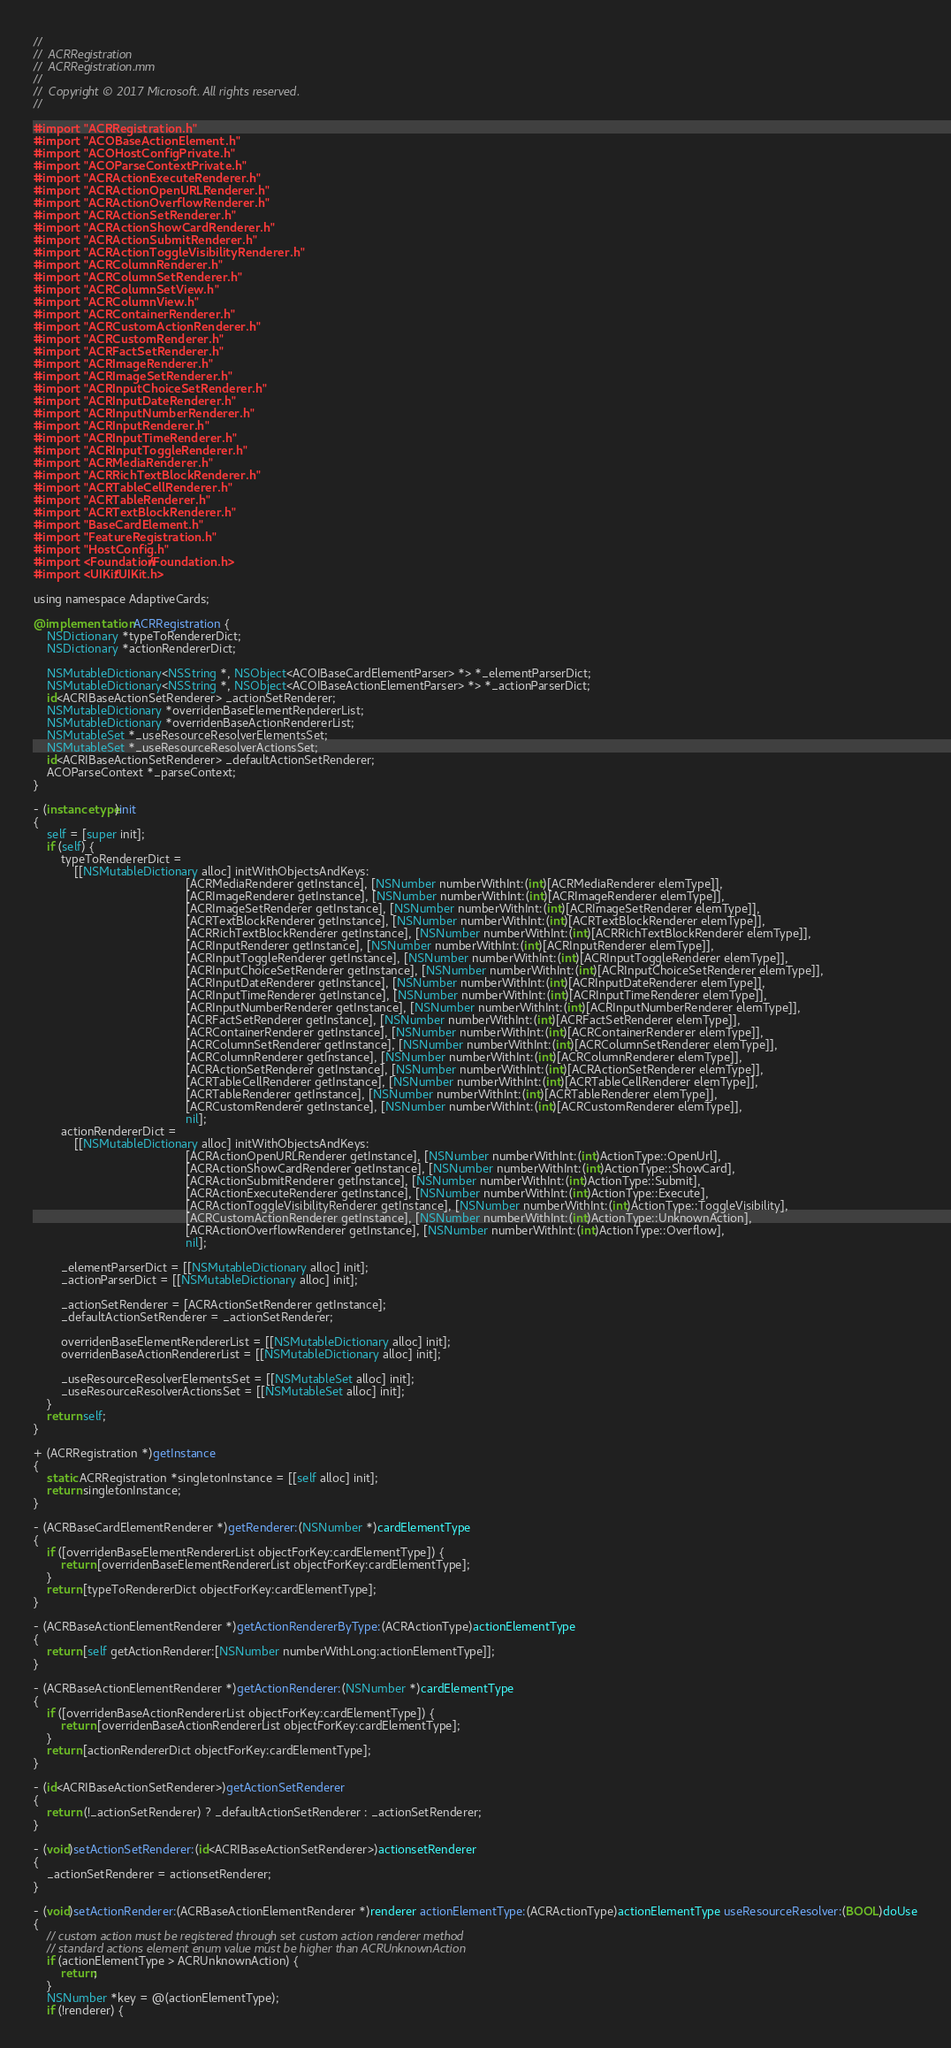Convert code to text. <code><loc_0><loc_0><loc_500><loc_500><_ObjectiveC_>//
//  ACRRegistration
//  ACRRegistration.mm
//
//  Copyright © 2017 Microsoft. All rights reserved.
//

#import "ACRRegistration.h"
#import "ACOBaseActionElement.h"
#import "ACOHostConfigPrivate.h"
#import "ACOParseContextPrivate.h"
#import "ACRActionExecuteRenderer.h"
#import "ACRActionOpenURLRenderer.h"
#import "ACRActionOverflowRenderer.h"
#import "ACRActionSetRenderer.h"
#import "ACRActionShowCardRenderer.h"
#import "ACRActionSubmitRenderer.h"
#import "ACRActionToggleVisibilityRenderer.h"
#import "ACRColumnRenderer.h"
#import "ACRColumnSetRenderer.h"
#import "ACRColumnSetView.h"
#import "ACRColumnView.h"
#import "ACRContainerRenderer.h"
#import "ACRCustomActionRenderer.h"
#import "ACRCustomRenderer.h"
#import "ACRFactSetRenderer.h"
#import "ACRImageRenderer.h"
#import "ACRImageSetRenderer.h"
#import "ACRInputChoiceSetRenderer.h"
#import "ACRInputDateRenderer.h"
#import "ACRInputNumberRenderer.h"
#import "ACRInputRenderer.h"
#import "ACRInputTimeRenderer.h"
#import "ACRInputToggleRenderer.h"
#import "ACRMediaRenderer.h"
#import "ACRRichTextBlockRenderer.h"
#import "ACRTableCellRenderer.h"
#import "ACRTableRenderer.h"
#import "ACRTextBlockRenderer.h"
#import "BaseCardElement.h"
#import "FeatureRegistration.h"
#import "HostConfig.h"
#import <Foundation/Foundation.h>
#import <UIKit/UIKit.h>

using namespace AdaptiveCards;

@implementation ACRRegistration {
    NSDictionary *typeToRendererDict;
    NSDictionary *actionRendererDict;

    NSMutableDictionary<NSString *, NSObject<ACOIBaseCardElementParser> *> *_elementParserDict;
    NSMutableDictionary<NSString *, NSObject<ACOIBaseActionElementParser> *> *_actionParserDict;
    id<ACRIBaseActionSetRenderer> _actionSetRenderer;
    NSMutableDictionary *overridenBaseElementRendererList;
    NSMutableDictionary *overridenBaseActionRendererList;
    NSMutableSet *_useResourceResolverElementsSet;
    NSMutableSet *_useResourceResolverActionsSet;
    id<ACRIBaseActionSetRenderer> _defaultActionSetRenderer;
    ACOParseContext *_parseContext;
}

- (instancetype)init
{
    self = [super init];
    if (self) {
        typeToRendererDict =
            [[NSMutableDictionary alloc] initWithObjectsAndKeys:
                                             [ACRMediaRenderer getInstance], [NSNumber numberWithInt:(int)[ACRMediaRenderer elemType]],
                                             [ACRImageRenderer getInstance], [NSNumber numberWithInt:(int)[ACRImageRenderer elemType]],
                                             [ACRImageSetRenderer getInstance], [NSNumber numberWithInt:(int)[ACRImageSetRenderer elemType]],
                                             [ACRTextBlockRenderer getInstance], [NSNumber numberWithInt:(int)[ACRTextBlockRenderer elemType]],
                                             [ACRRichTextBlockRenderer getInstance], [NSNumber numberWithInt:(int)[ACRRichTextBlockRenderer elemType]],
                                             [ACRInputRenderer getInstance], [NSNumber numberWithInt:(int)[ACRInputRenderer elemType]],
                                             [ACRInputToggleRenderer getInstance], [NSNumber numberWithInt:(int)[ACRInputToggleRenderer elemType]],
                                             [ACRInputChoiceSetRenderer getInstance], [NSNumber numberWithInt:(int)[ACRInputChoiceSetRenderer elemType]],
                                             [ACRInputDateRenderer getInstance], [NSNumber numberWithInt:(int)[ACRInputDateRenderer elemType]],
                                             [ACRInputTimeRenderer getInstance], [NSNumber numberWithInt:(int)[ACRInputTimeRenderer elemType]],
                                             [ACRInputNumberRenderer getInstance], [NSNumber numberWithInt:(int)[ACRInputNumberRenderer elemType]],
                                             [ACRFactSetRenderer getInstance], [NSNumber numberWithInt:(int)[ACRFactSetRenderer elemType]],
                                             [ACRContainerRenderer getInstance], [NSNumber numberWithInt:(int)[ACRContainerRenderer elemType]],
                                             [ACRColumnSetRenderer getInstance], [NSNumber numberWithInt:(int)[ACRColumnSetRenderer elemType]],
                                             [ACRColumnRenderer getInstance], [NSNumber numberWithInt:(int)[ACRColumnRenderer elemType]],
                                             [ACRActionSetRenderer getInstance], [NSNumber numberWithInt:(int)[ACRActionSetRenderer elemType]],
                                             [ACRTableCellRenderer getInstance], [NSNumber numberWithInt:(int)[ACRTableCellRenderer elemType]],
                                             [ACRTableRenderer getInstance], [NSNumber numberWithInt:(int)[ACRTableRenderer elemType]],
                                             [ACRCustomRenderer getInstance], [NSNumber numberWithInt:(int)[ACRCustomRenderer elemType]],
                                             nil];
        actionRendererDict =
            [[NSMutableDictionary alloc] initWithObjectsAndKeys:
                                             [ACRActionOpenURLRenderer getInstance], [NSNumber numberWithInt:(int)ActionType::OpenUrl],
                                             [ACRActionShowCardRenderer getInstance], [NSNumber numberWithInt:(int)ActionType::ShowCard],
                                             [ACRActionSubmitRenderer getInstance], [NSNumber numberWithInt:(int)ActionType::Submit],
                                             [ACRActionExecuteRenderer getInstance], [NSNumber numberWithInt:(int)ActionType::Execute],
                                             [ACRActionToggleVisibilityRenderer getInstance], [NSNumber numberWithInt:(int)ActionType::ToggleVisibility],
                                             [ACRCustomActionRenderer getInstance], [NSNumber numberWithInt:(int)ActionType::UnknownAction],
                                             [ACRActionOverflowRenderer getInstance], [NSNumber numberWithInt:(int)ActionType::Overflow],
                                             nil];

        _elementParserDict = [[NSMutableDictionary alloc] init];
        _actionParserDict = [[NSMutableDictionary alloc] init];

        _actionSetRenderer = [ACRActionSetRenderer getInstance];
        _defaultActionSetRenderer = _actionSetRenderer;

        overridenBaseElementRendererList = [[NSMutableDictionary alloc] init];
        overridenBaseActionRendererList = [[NSMutableDictionary alloc] init];

        _useResourceResolverElementsSet = [[NSMutableSet alloc] init];
        _useResourceResolverActionsSet = [[NSMutableSet alloc] init];
    }
    return self;
}

+ (ACRRegistration *)getInstance
{
    static ACRRegistration *singletonInstance = [[self alloc] init];
    return singletonInstance;
}

- (ACRBaseCardElementRenderer *)getRenderer:(NSNumber *)cardElementType
{
    if ([overridenBaseElementRendererList objectForKey:cardElementType]) {
        return [overridenBaseElementRendererList objectForKey:cardElementType];
    }
    return [typeToRendererDict objectForKey:cardElementType];
}

- (ACRBaseActionElementRenderer *)getActionRendererByType:(ACRActionType)actionElementType
{
    return [self getActionRenderer:[NSNumber numberWithLong:actionElementType]];
}

- (ACRBaseActionElementRenderer *)getActionRenderer:(NSNumber *)cardElementType
{
    if ([overridenBaseActionRendererList objectForKey:cardElementType]) {
        return [overridenBaseActionRendererList objectForKey:cardElementType];
    }
    return [actionRendererDict objectForKey:cardElementType];
}

- (id<ACRIBaseActionSetRenderer>)getActionSetRenderer
{
    return (!_actionSetRenderer) ? _defaultActionSetRenderer : _actionSetRenderer;
}

- (void)setActionSetRenderer:(id<ACRIBaseActionSetRenderer>)actionsetRenderer
{
    _actionSetRenderer = actionsetRenderer;
}

- (void)setActionRenderer:(ACRBaseActionElementRenderer *)renderer actionElementType:(ACRActionType)actionElementType useResourceResolver:(BOOL)doUse
{
    // custom action must be registered through set custom action renderer method
    // standard actions element enum value must be higher than ACRUnknownAction
    if (actionElementType > ACRUnknownAction) {
        return;
    }
    NSNumber *key = @(actionElementType);
    if (!renderer) {</code> 